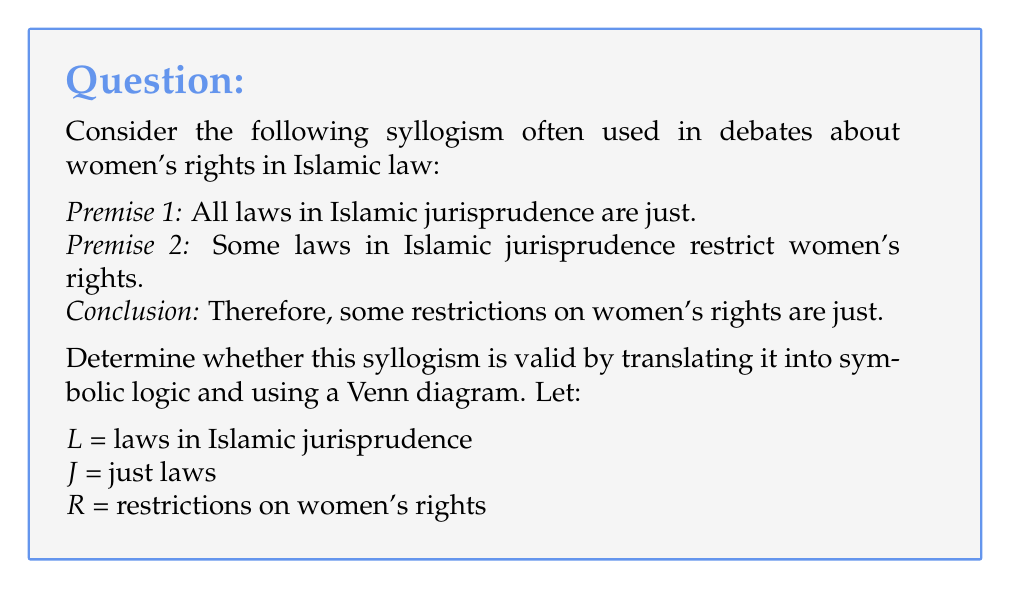Teach me how to tackle this problem. To determine the validity of this syllogism, we'll follow these steps:

1. Translate the premises and conclusion into symbolic logic:
   Premise 1: $\forall x (L(x) \rightarrow J(x))$
   Premise 2: $\exists x (L(x) \land R(x))$
   Conclusion: $\exists x (R(x) \land J(x))$

2. Draw a Venn diagram with three circles representing L, J, and R.

3. Represent the premises on the Venn diagram:
   - For Premise 1, shade out the area of L that is not in J.
   - For Premise 2, place an X in the overlapping area of L and R.

4. Check if the conclusion is necessarily true based on the diagram.

[asy]
unitsize(1cm);

pair C1 = (0,0), C2 = (1.5,0), C3 = (0.75,1.3);
real r = 1.2;

path c1 = circle(C1, r);
path c2 = circle(C2, r);
path c3 = circle(C3, r);

fill(c1, lightgray);
fill(c2, white);
fill(c3, white);

draw(c1);
draw(c2);
draw(c3);

label("L", C1 + (-0.8,-0.8));
label("J", C2 + (0.8,-0.8));
label("R", C3 + (0,1));

fill(c1 - c2, gray);
dot((0.4,0.2), red+3);

label("X", (0.4,0.2), SE, red);
[/asy]

5. Analyze the diagram:
   - The X representing Premise 2 is in the overlapping area of L and R.
   - Due to Premise 1, this X must also be in J (as all of L is in J).
   - Therefore, there exists an element in the intersection of R and J.

6. Conclusion:
   The Venn diagram shows that the conclusion necessarily follows from the premises. There is an X in the region where R and J overlap, which represents the existence of "some restrictions on women's rights that are just."
Answer: The syllogism is valid. The Venn diagram demonstrates that the conclusion logically follows from the premises, as there exists an element in the intersection of R (restrictions on women's rights) and J (just laws). 